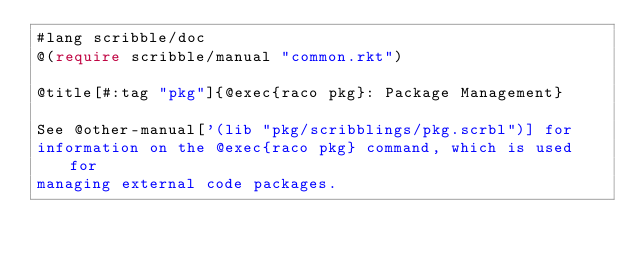<code> <loc_0><loc_0><loc_500><loc_500><_Racket_>#lang scribble/doc
@(require scribble/manual "common.rkt")

@title[#:tag "pkg"]{@exec{raco pkg}: Package Management}

See @other-manual['(lib "pkg/scribblings/pkg.scrbl")] for
information on the @exec{raco pkg} command, which is used for
managing external code packages.
</code> 